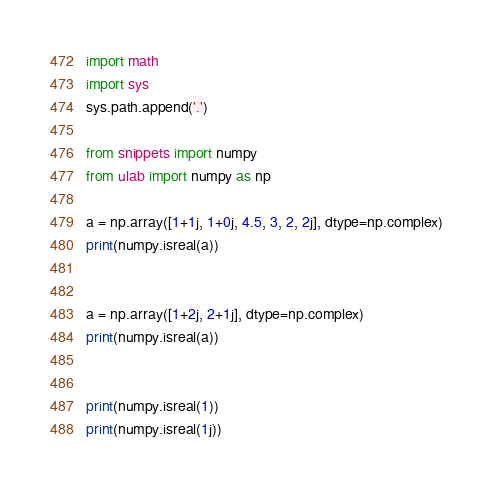Convert code to text. <code><loc_0><loc_0><loc_500><loc_500><_Python_>import math
import sys
sys.path.append('.')

from snippets import numpy
from ulab import numpy as np

a = np.array([1+1j, 1+0j, 4.5, 3, 2, 2j], dtype=np.complex)
print(numpy.isreal(a))


a = np.array([1+2j, 2+1j], dtype=np.complex)
print(numpy.isreal(a))


print(numpy.isreal(1))
print(numpy.isreal(1j))</code> 